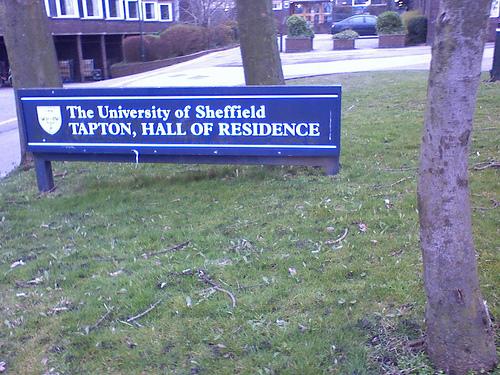Is this a school?
Concise answer only. Yes. What kind of building does the sign denote?
Give a very brief answer. Hall of residence. How many windows are visible on the building?
Short answer required. 6. 